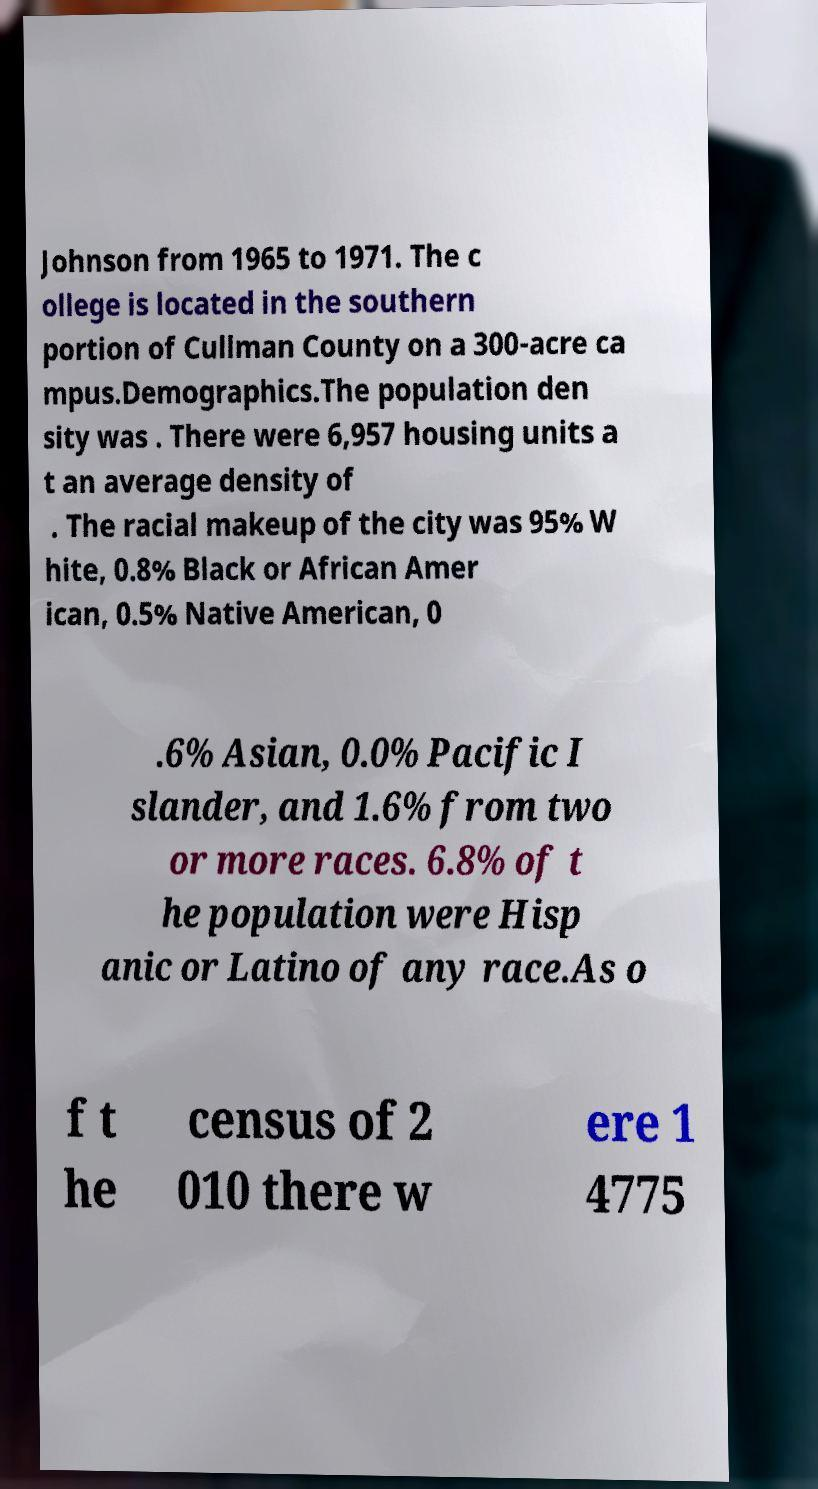Can you accurately transcribe the text from the provided image for me? Johnson from 1965 to 1971. The c ollege is located in the southern portion of Cullman County on a 300-acre ca mpus.Demographics.The population den sity was . There were 6,957 housing units a t an average density of . The racial makeup of the city was 95% W hite, 0.8% Black or African Amer ican, 0.5% Native American, 0 .6% Asian, 0.0% Pacific I slander, and 1.6% from two or more races. 6.8% of t he population were Hisp anic or Latino of any race.As o f t he census of 2 010 there w ere 1 4775 